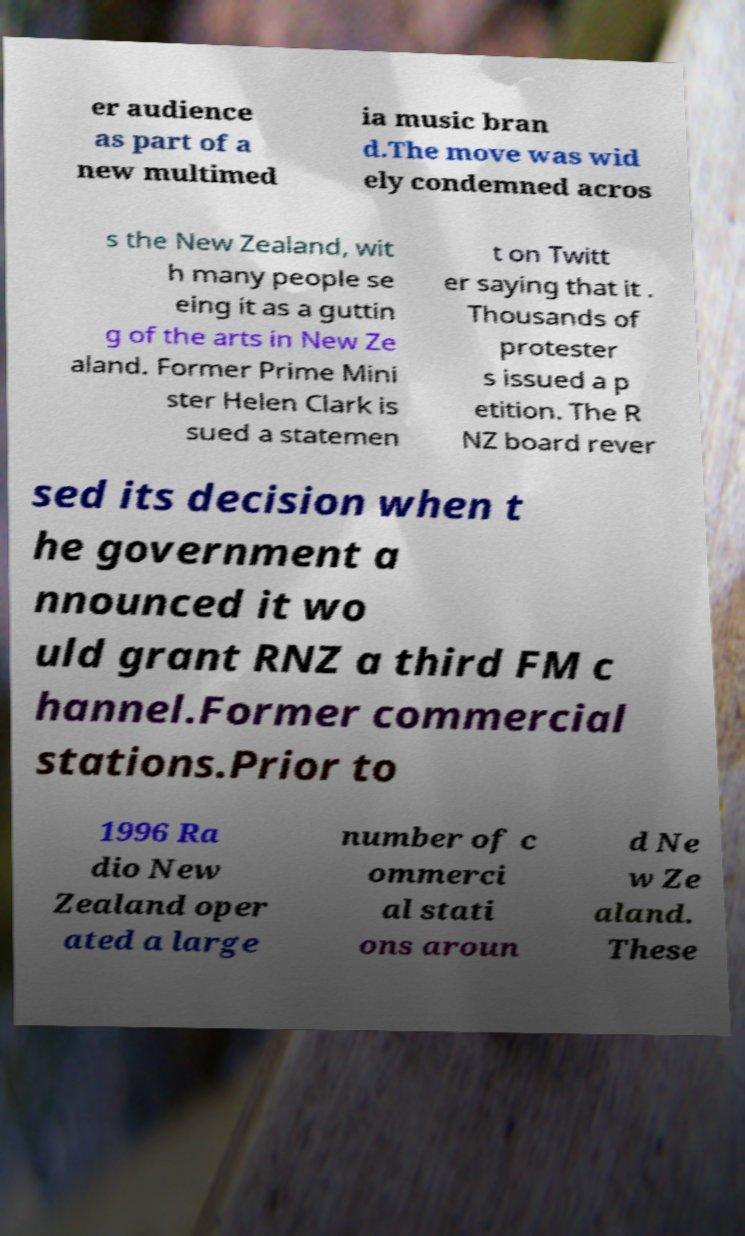Could you assist in decoding the text presented in this image and type it out clearly? er audience as part of a new multimed ia music bran d.The move was wid ely condemned acros s the New Zealand, wit h many people se eing it as a guttin g of the arts in New Ze aland. Former Prime Mini ster Helen Clark is sued a statemen t on Twitt er saying that it . Thousands of protester s issued a p etition. The R NZ board rever sed its decision when t he government a nnounced it wo uld grant RNZ a third FM c hannel.Former commercial stations.Prior to 1996 Ra dio New Zealand oper ated a large number of c ommerci al stati ons aroun d Ne w Ze aland. These 